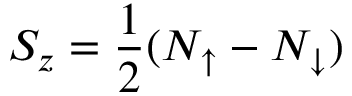<formula> <loc_0><loc_0><loc_500><loc_500>S _ { z } = \frac { 1 } { 2 } ( N _ { \uparrow } - N _ { \downarrow } )</formula> 